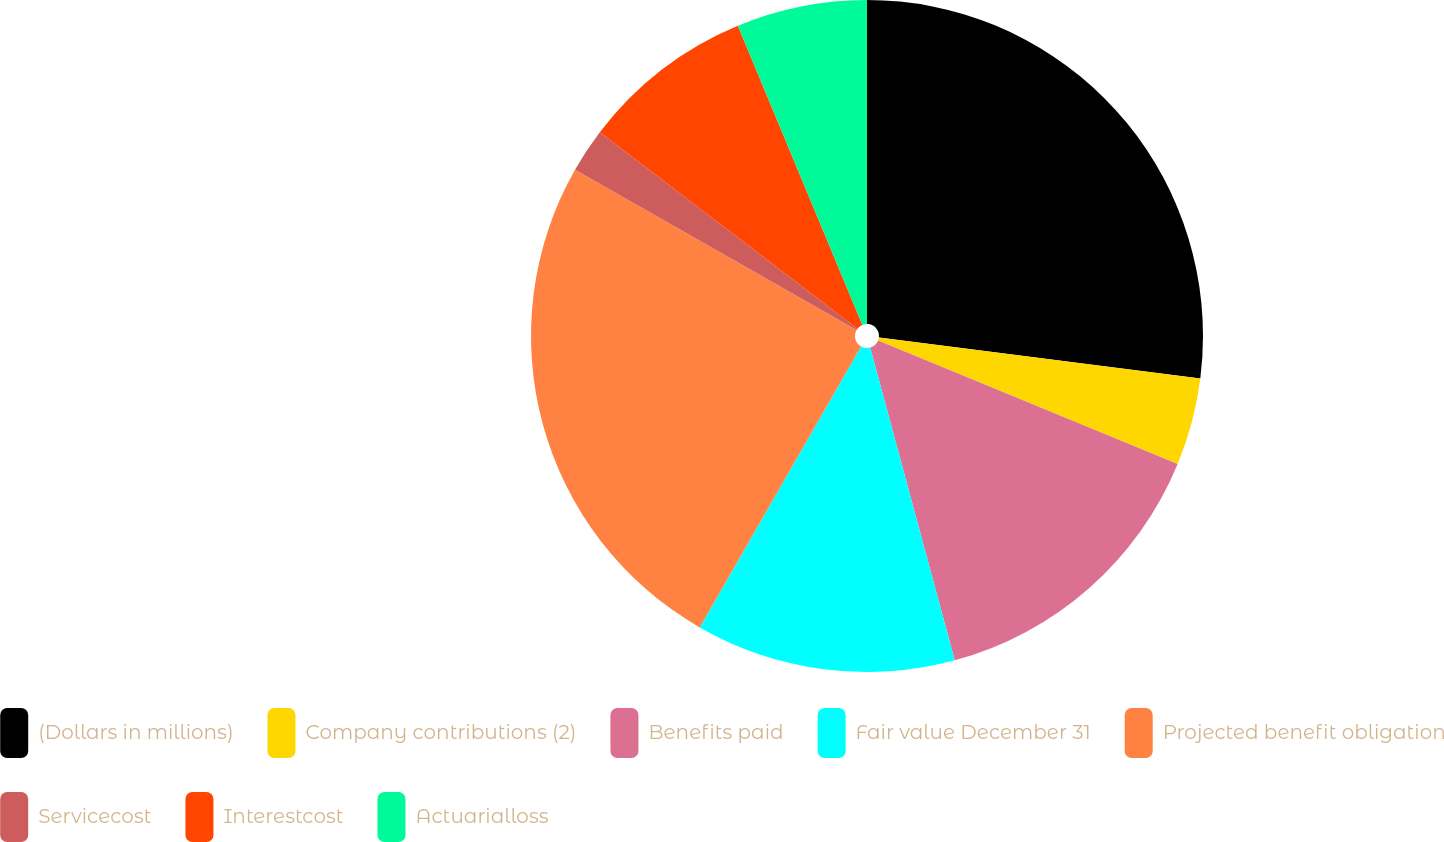Convert chart. <chart><loc_0><loc_0><loc_500><loc_500><pie_chart><fcel>(Dollars in millions)<fcel>Company contributions (2)<fcel>Benefits paid<fcel>Fair value December 31<fcel>Projected benefit obligation<fcel>Servicecost<fcel>Interestcost<fcel>Actuarialloss<nl><fcel>27.01%<fcel>4.21%<fcel>14.57%<fcel>12.5%<fcel>24.94%<fcel>2.13%<fcel>8.35%<fcel>6.28%<nl></chart> 